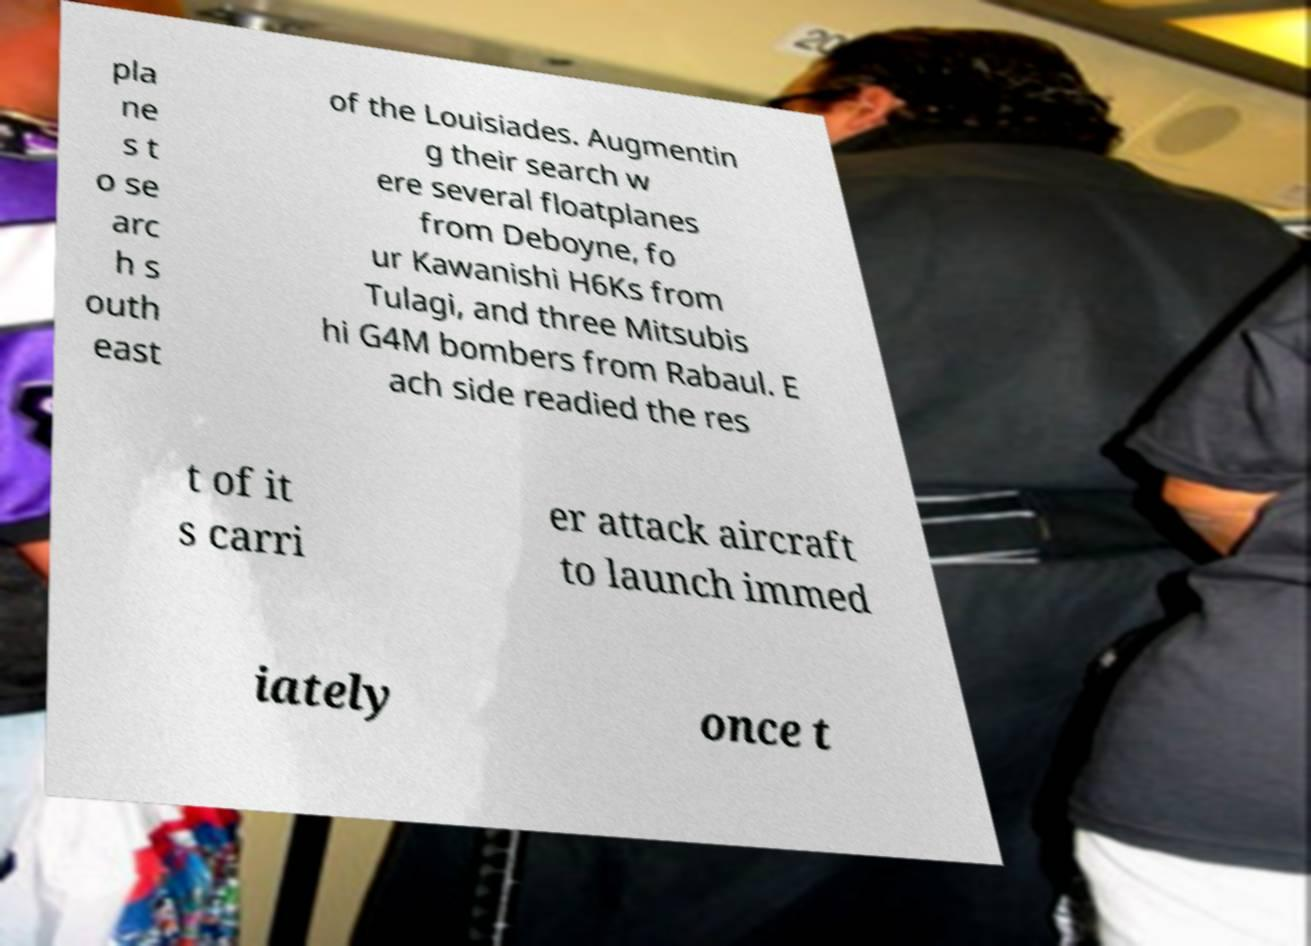Could you assist in decoding the text presented in this image and type it out clearly? pla ne s t o se arc h s outh east of the Louisiades. Augmentin g their search w ere several floatplanes from Deboyne, fo ur Kawanishi H6Ks from Tulagi, and three Mitsubis hi G4M bombers from Rabaul. E ach side readied the res t of it s carri er attack aircraft to launch immed iately once t 